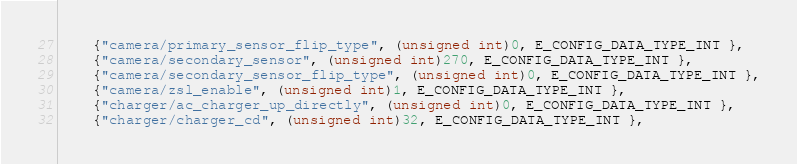Convert code to text. <code><loc_0><loc_0><loc_500><loc_500><_C_>    {"camera/primary_sensor_flip_type", (unsigned int)0, E_CONFIG_DATA_TYPE_INT },
    {"camera/secondary_sensor", (unsigned int)270, E_CONFIG_DATA_TYPE_INT },
    {"camera/secondary_sensor_flip_type", (unsigned int)0, E_CONFIG_DATA_TYPE_INT },
    {"camera/zsl_enable", (unsigned int)1, E_CONFIG_DATA_TYPE_INT },
    {"charger/ac_charger_up_directly", (unsigned int)0, E_CONFIG_DATA_TYPE_INT },
    {"charger/charger_cd", (unsigned int)32, E_CONFIG_DATA_TYPE_INT },</code> 